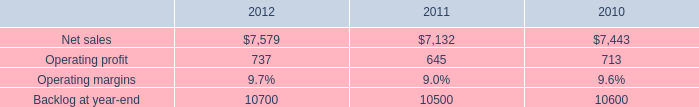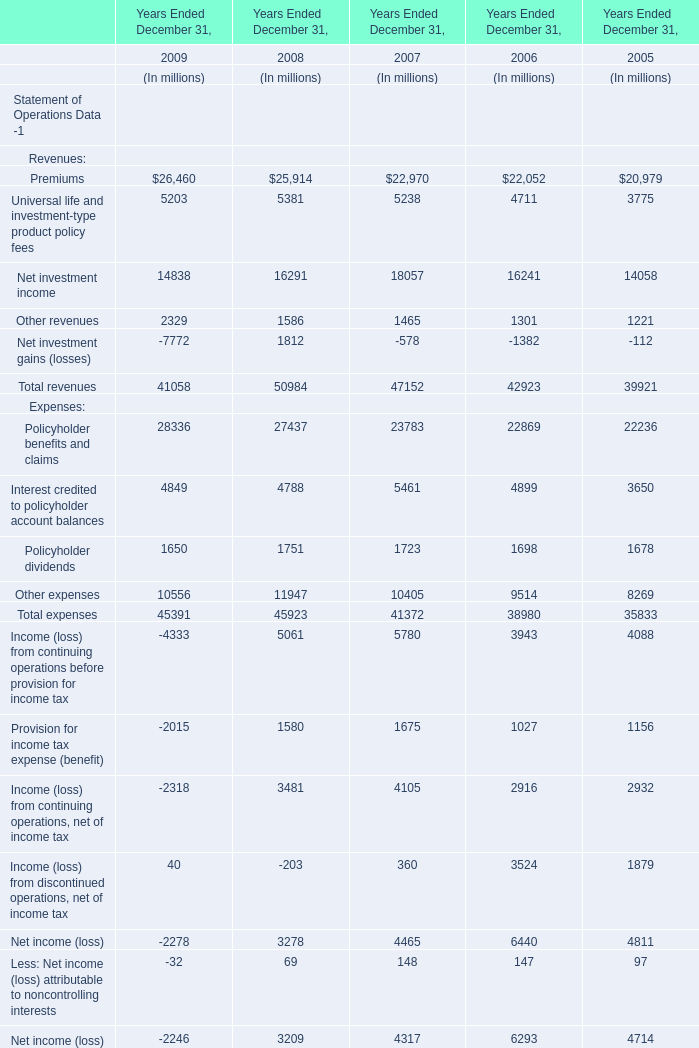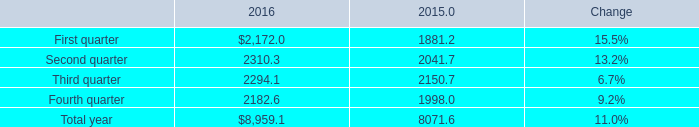what is the growth rate in operating profit for mst in 2011? 
Computations: ((645 - 713) / 713)
Answer: -0.09537. 